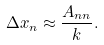<formula> <loc_0><loc_0><loc_500><loc_500>\Delta x _ { n } \approx \frac { A _ { n n } } { k } .</formula> 